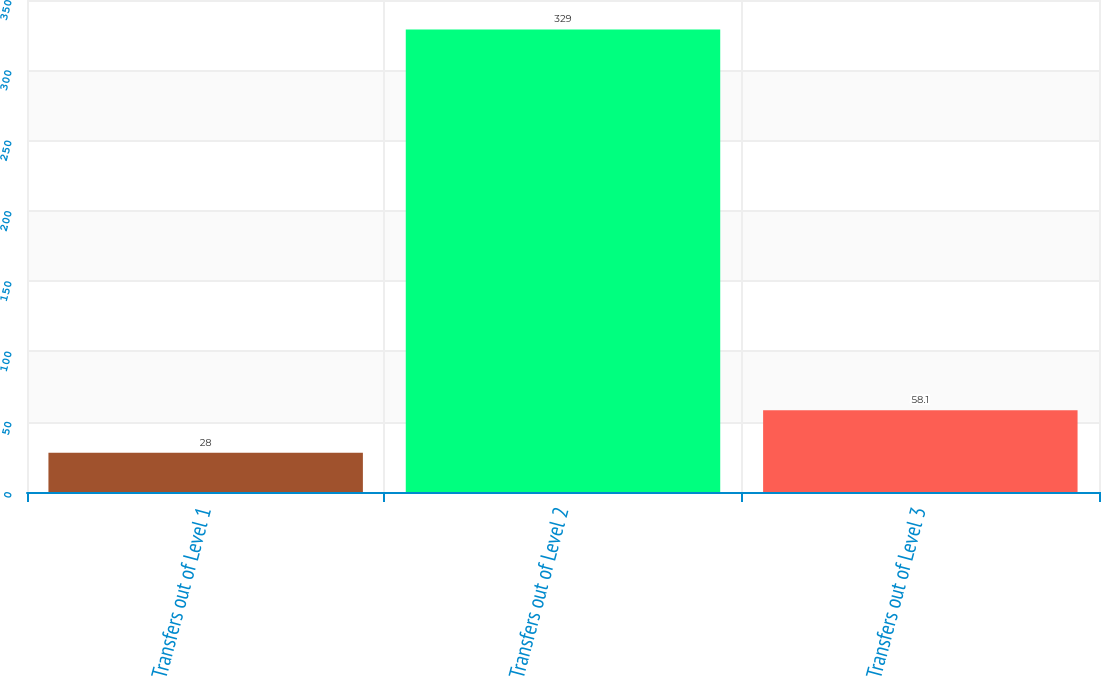Convert chart. <chart><loc_0><loc_0><loc_500><loc_500><bar_chart><fcel>Transfers out of Level 1<fcel>Transfers out of Level 2<fcel>Transfers out of Level 3<nl><fcel>28<fcel>329<fcel>58.1<nl></chart> 